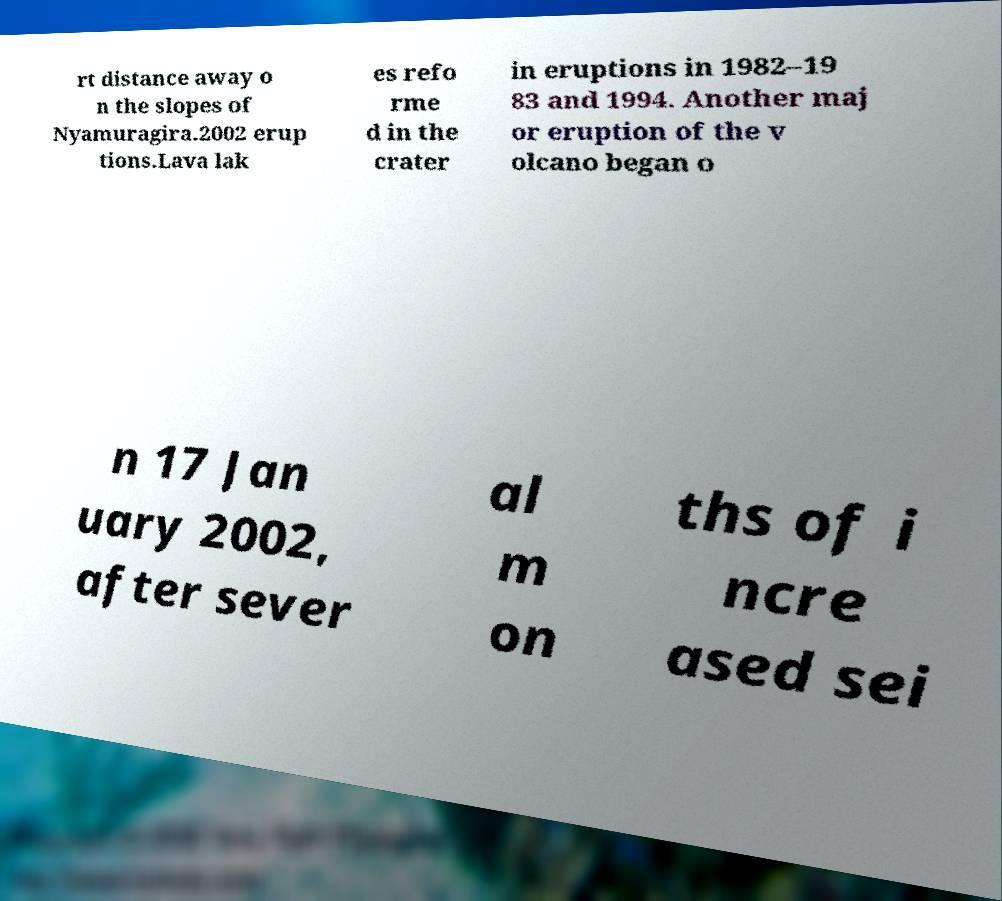I need the written content from this picture converted into text. Can you do that? rt distance away o n the slopes of Nyamuragira.2002 erup tions.Lava lak es refo rme d in the crater in eruptions in 1982–19 83 and 1994. Another maj or eruption of the v olcano began o n 17 Jan uary 2002, after sever al m on ths of i ncre ased sei 